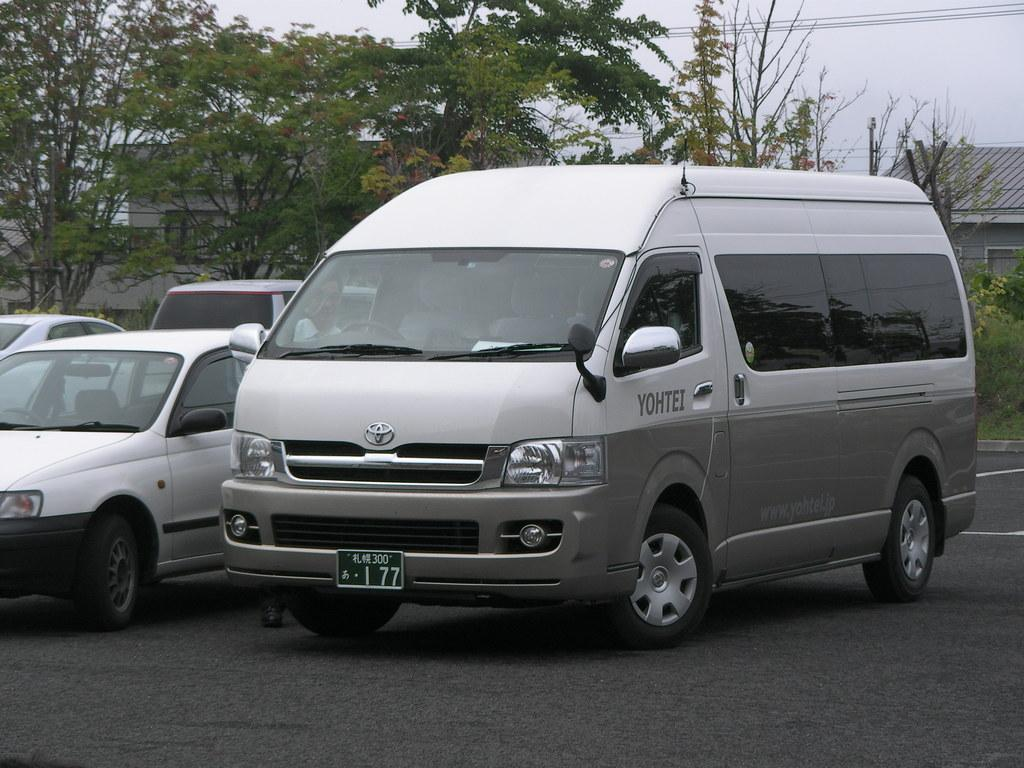<image>
Summarize the visual content of the image. A white and grey van is parked in a lot and says Yohtei on the driver's door. 